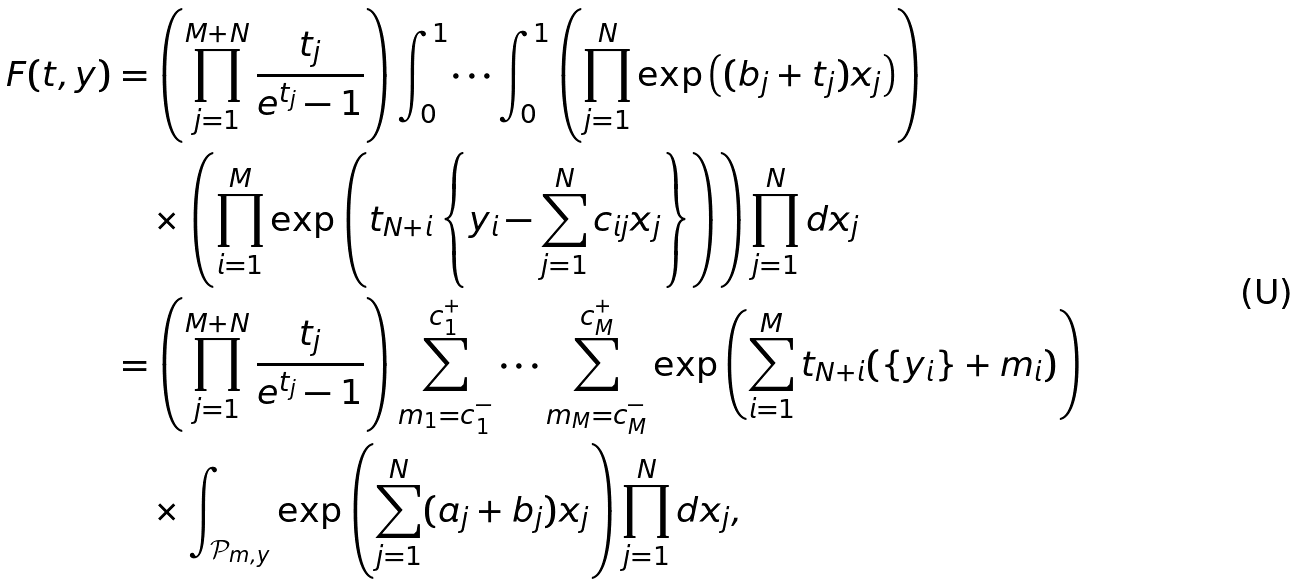<formula> <loc_0><loc_0><loc_500><loc_500>F ( t , y ) & = \left ( \prod _ { j = 1 } ^ { M + N } \frac { t _ { j } } { e ^ { t _ { j } } - 1 } \right ) \int _ { 0 } ^ { 1 } \dots \int _ { 0 } ^ { 1 } \left ( \prod _ { j = 1 } ^ { N } \exp \left ( ( b _ { j } + t _ { j } ) x _ { j } \right ) \right ) \\ & \quad \times \left ( \prod _ { i = 1 } ^ { M } \exp \left ( t _ { N + i } \left \{ y _ { i } - \sum _ { j = 1 } ^ { N } c _ { i j } x _ { j } \right \} \right ) \right ) \prod _ { j = 1 } ^ { N } d x _ { j } \\ & = \left ( \prod _ { j = 1 } ^ { M + N } \frac { t _ { j } } { e ^ { t _ { j } } - 1 } \right ) \sum _ { m _ { 1 } = c _ { 1 } ^ { - } } ^ { c _ { 1 } ^ { + } } \cdots \sum _ { m _ { M } = c _ { M } ^ { - } } ^ { c _ { M } ^ { + } } \exp \left ( \sum _ { i = 1 } ^ { M } t _ { N + i } ( \{ y _ { i } \} + m _ { i } ) \right ) \\ & \quad \times \int _ { \mathcal { P } _ { m , y } } \exp \left ( \sum _ { j = 1 } ^ { N } ( a _ { j } + b _ { j } ) x _ { j } \right ) \prod _ { j = 1 } ^ { N } d x _ { j } ,</formula> 